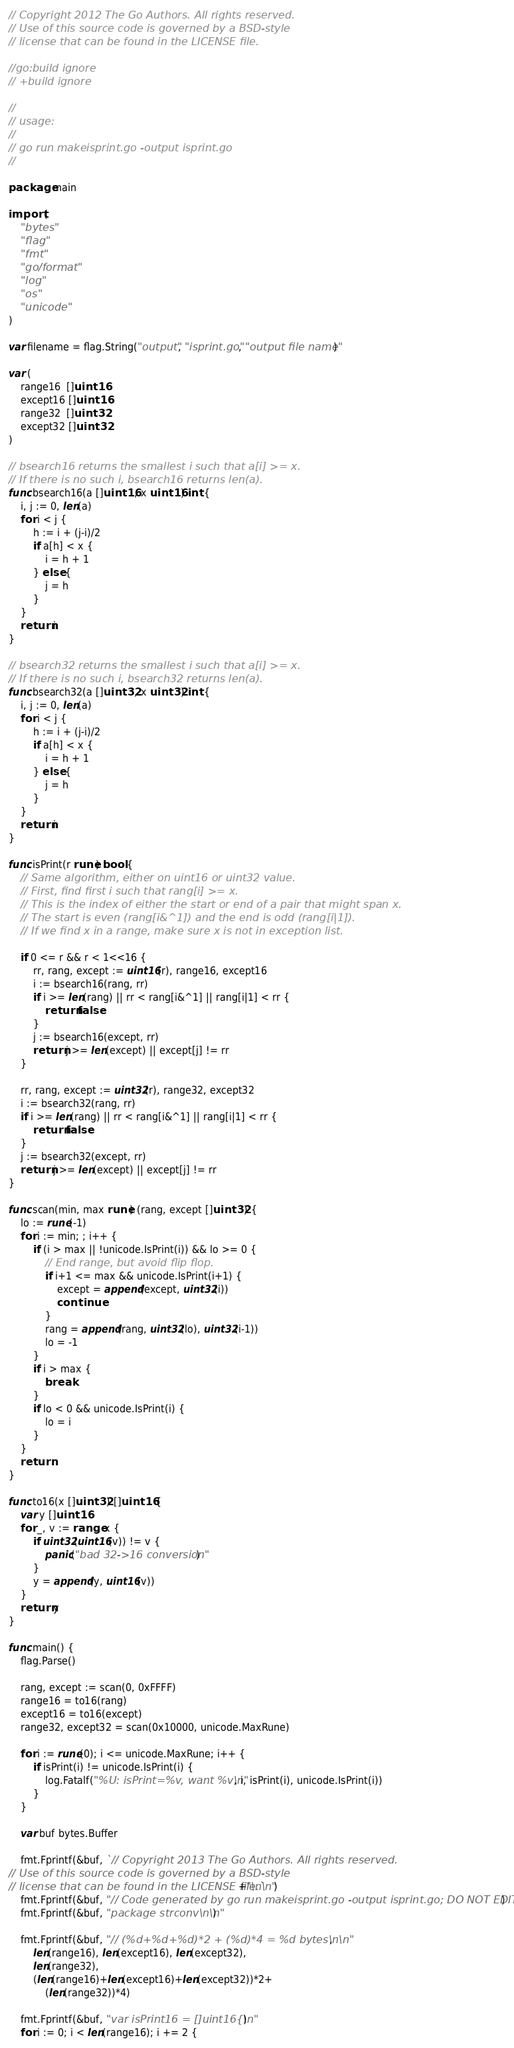Convert code to text. <code><loc_0><loc_0><loc_500><loc_500><_Go_>// Copyright 2012 The Go Authors. All rights reserved.
// Use of this source code is governed by a BSD-style
// license that can be found in the LICENSE file.

//go:build ignore
// +build ignore

//
// usage:
//
// go run makeisprint.go -output isprint.go
//

package main

import (
	"bytes"
	"flag"
	"fmt"
	"go/format"
	"log"
	"os"
	"unicode"
)

var filename = flag.String("output", "isprint.go", "output file name")

var (
	range16  []uint16
	except16 []uint16
	range32  []uint32
	except32 []uint32
)

// bsearch16 returns the smallest i such that a[i] >= x.
// If there is no such i, bsearch16 returns len(a).
func bsearch16(a []uint16, x uint16) int {
	i, j := 0, len(a)
	for i < j {
		h := i + (j-i)/2
		if a[h] < x {
			i = h + 1
		} else {
			j = h
		}
	}
	return i
}

// bsearch32 returns the smallest i such that a[i] >= x.
// If there is no such i, bsearch32 returns len(a).
func bsearch32(a []uint32, x uint32) int {
	i, j := 0, len(a)
	for i < j {
		h := i + (j-i)/2
		if a[h] < x {
			i = h + 1
		} else {
			j = h
		}
	}
	return i
}

func isPrint(r rune) bool {
	// Same algorithm, either on uint16 or uint32 value.
	// First, find first i such that rang[i] >= x.
	// This is the index of either the start or end of a pair that might span x.
	// The start is even (rang[i&^1]) and the end is odd (rang[i|1]).
	// If we find x in a range, make sure x is not in exception list.

	if 0 <= r && r < 1<<16 {
		rr, rang, except := uint16(r), range16, except16
		i := bsearch16(rang, rr)
		if i >= len(rang) || rr < rang[i&^1] || rang[i|1] < rr {
			return false
		}
		j := bsearch16(except, rr)
		return j >= len(except) || except[j] != rr
	}

	rr, rang, except := uint32(r), range32, except32
	i := bsearch32(rang, rr)
	if i >= len(rang) || rr < rang[i&^1] || rang[i|1] < rr {
		return false
	}
	j := bsearch32(except, rr)
	return j >= len(except) || except[j] != rr
}

func scan(min, max rune) (rang, except []uint32) {
	lo := rune(-1)
	for i := min; ; i++ {
		if (i > max || !unicode.IsPrint(i)) && lo >= 0 {
			// End range, but avoid flip flop.
			if i+1 <= max && unicode.IsPrint(i+1) {
				except = append(except, uint32(i))
				continue
			}
			rang = append(rang, uint32(lo), uint32(i-1))
			lo = -1
		}
		if i > max {
			break
		}
		if lo < 0 && unicode.IsPrint(i) {
			lo = i
		}
	}
	return
}

func to16(x []uint32) []uint16 {
	var y []uint16
	for _, v := range x {
		if uint32(uint16(v)) != v {
			panic("bad 32->16 conversion")
		}
		y = append(y, uint16(v))
	}
	return y
}

func main() {
	flag.Parse()

	rang, except := scan(0, 0xFFFF)
	range16 = to16(rang)
	except16 = to16(except)
	range32, except32 = scan(0x10000, unicode.MaxRune)

	for i := rune(0); i <= unicode.MaxRune; i++ {
		if isPrint(i) != unicode.IsPrint(i) {
			log.Fatalf("%U: isPrint=%v, want %v\n", i, isPrint(i), unicode.IsPrint(i))
		}
	}

	var buf bytes.Buffer

	fmt.Fprintf(&buf, `// Copyright 2013 The Go Authors. All rights reserved.
// Use of this source code is governed by a BSD-style
// license that can be found in the LICENSE file.`+"\n\n")
	fmt.Fprintf(&buf, "// Code generated by go run makeisprint.go -output isprint.go; DO NOT EDIT.\n\n")
	fmt.Fprintf(&buf, "package strconv\n\n")

	fmt.Fprintf(&buf, "// (%d+%d+%d)*2 + (%d)*4 = %d bytes\n\n",
		len(range16), len(except16), len(except32),
		len(range32),
		(len(range16)+len(except16)+len(except32))*2+
			(len(range32))*4)

	fmt.Fprintf(&buf, "var isPrint16 = []uint16{\n")
	for i := 0; i < len(range16); i += 2 {</code> 